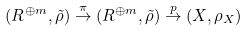Convert formula to latex. <formula><loc_0><loc_0><loc_500><loc_500>( R ^ { \oplus m } , \tilde { \rho } ) \overset { \pi } { \to } ( R ^ { \oplus m } , \tilde { \rho } ) \overset { p } { \to } ( X , \rho _ { X } )</formula> 